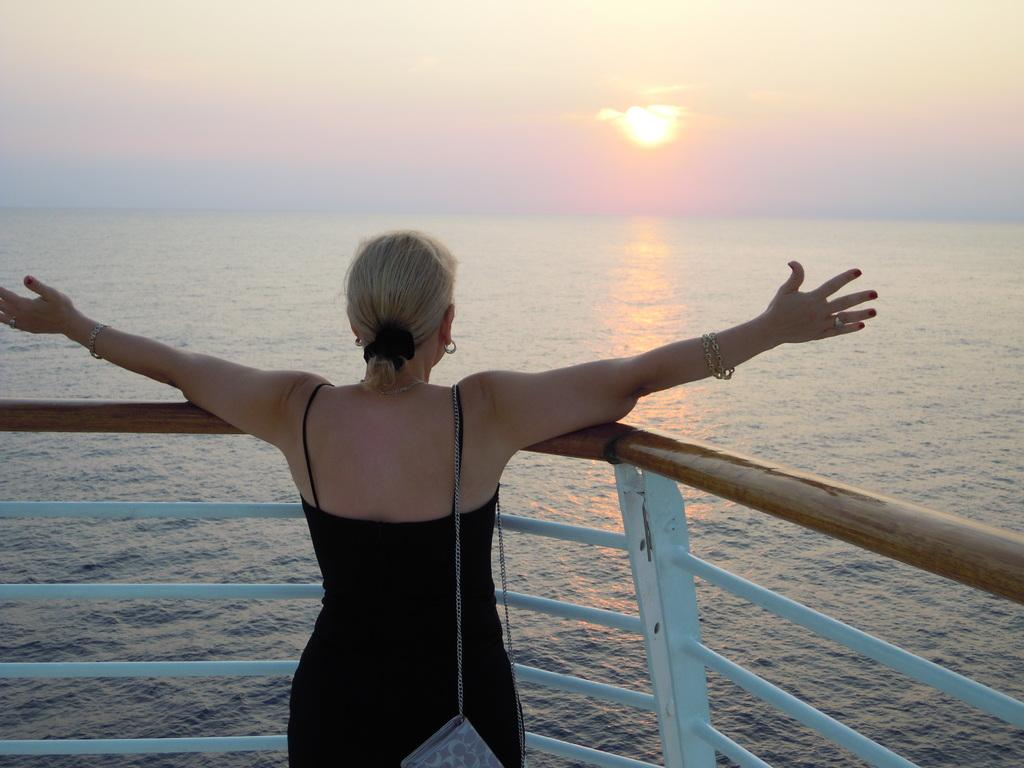What is the main subject of the image? There is a woman standing in the image. What is in front of the woman? There is a river in front of the woman. What can be seen in the background of the image? The sky is visible in the background of the image. What impulse is the woman experiencing in the image? There is no indication of any impulse the woman might be experiencing in the image. 